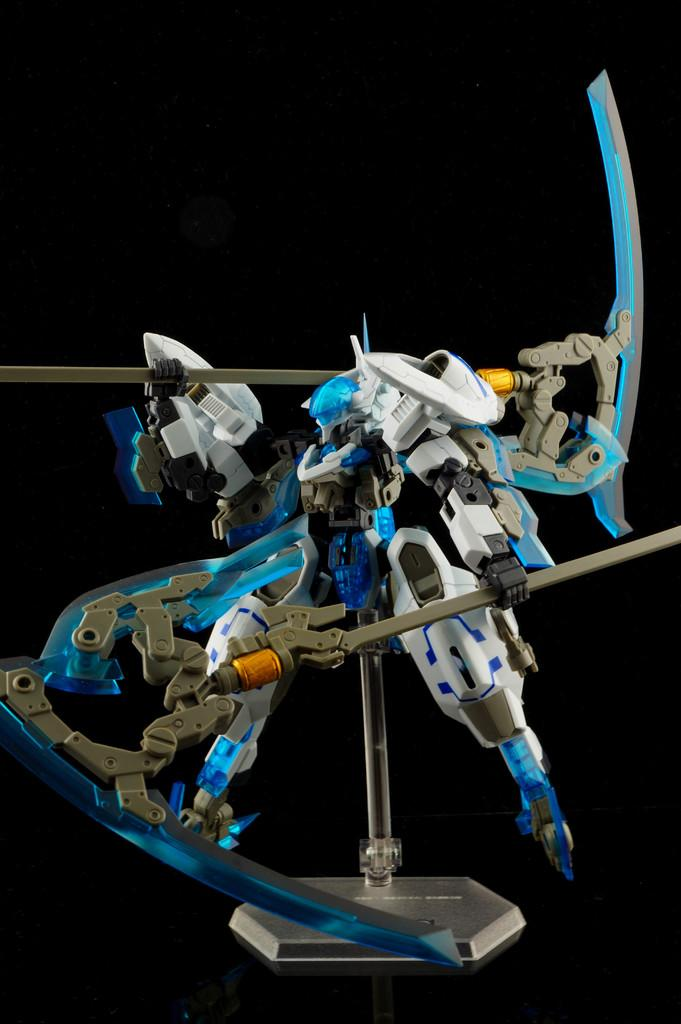What object is present in the image? There is a toy in the image. What colors can be seen on the toy? The toy has blue, white, yellow, orange, and grey colors. What is the color of the background in the image? The background of the image is black. Can you see any feathers on the toy in the image? There are no feathers present on the toy in the image. Is there a tiger visible in the image? There is no tiger present in the image; it features a toy with various colors. 